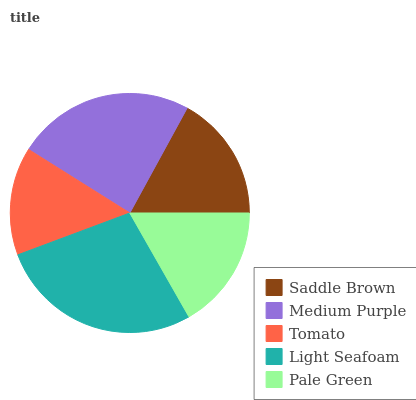Is Tomato the minimum?
Answer yes or no. Yes. Is Light Seafoam the maximum?
Answer yes or no. Yes. Is Medium Purple the minimum?
Answer yes or no. No. Is Medium Purple the maximum?
Answer yes or no. No. Is Medium Purple greater than Saddle Brown?
Answer yes or no. Yes. Is Saddle Brown less than Medium Purple?
Answer yes or no. Yes. Is Saddle Brown greater than Medium Purple?
Answer yes or no. No. Is Medium Purple less than Saddle Brown?
Answer yes or no. No. Is Saddle Brown the high median?
Answer yes or no. Yes. Is Saddle Brown the low median?
Answer yes or no. Yes. Is Light Seafoam the high median?
Answer yes or no. No. Is Medium Purple the low median?
Answer yes or no. No. 